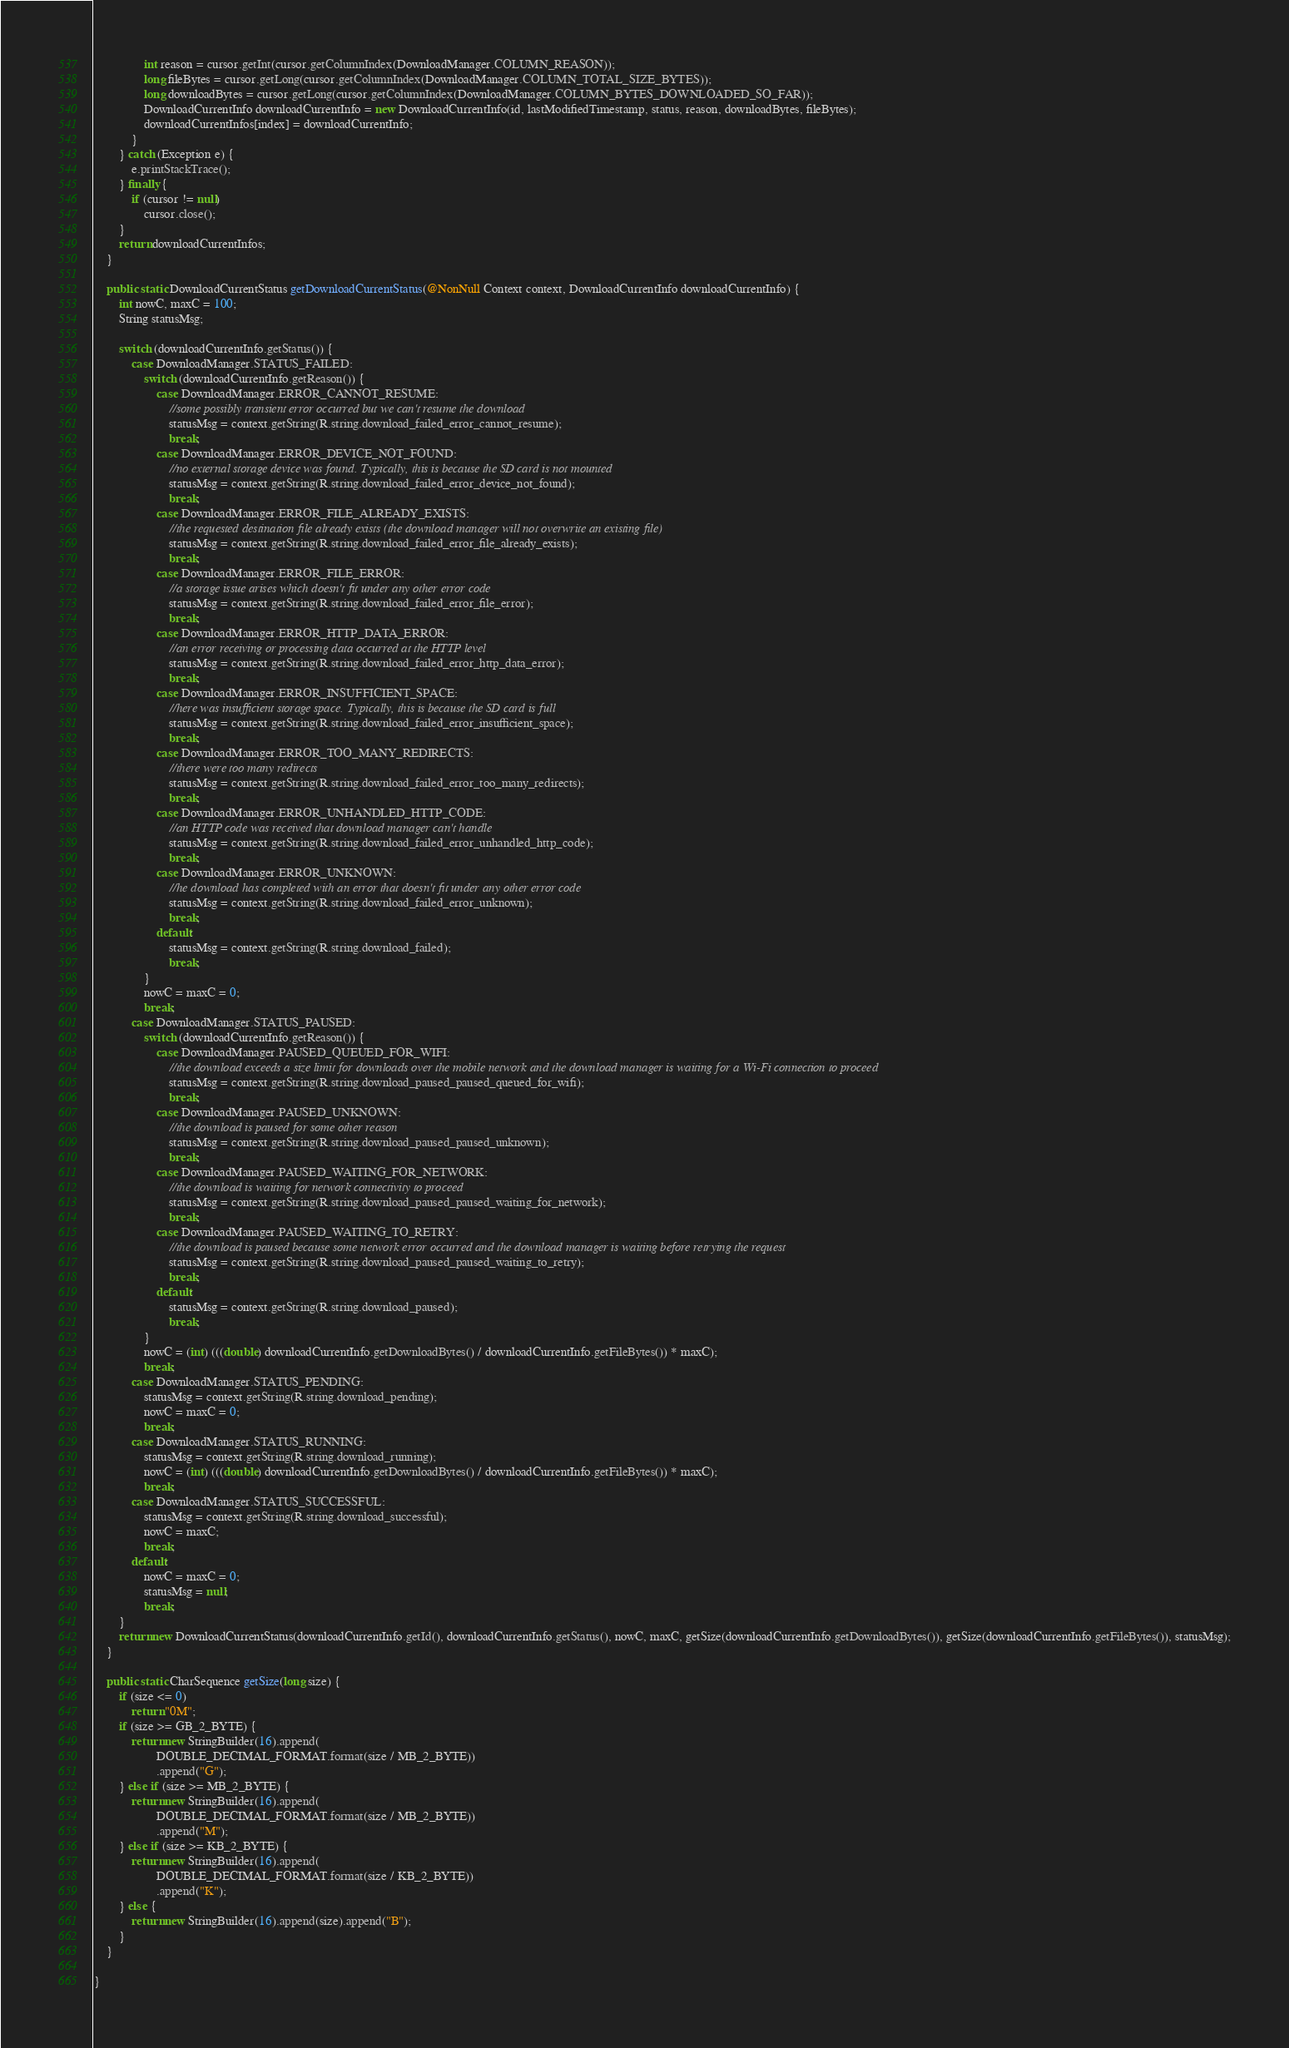<code> <loc_0><loc_0><loc_500><loc_500><_Java_>                int reason = cursor.getInt(cursor.getColumnIndex(DownloadManager.COLUMN_REASON));
                long fileBytes = cursor.getLong(cursor.getColumnIndex(DownloadManager.COLUMN_TOTAL_SIZE_BYTES));
                long downloadBytes = cursor.getLong(cursor.getColumnIndex(DownloadManager.COLUMN_BYTES_DOWNLOADED_SO_FAR));
                DownloadCurrentInfo downloadCurrentInfo = new DownloadCurrentInfo(id, lastModifiedTimestamp, status, reason, downloadBytes, fileBytes);
                downloadCurrentInfos[index] = downloadCurrentInfo;
            }
        } catch (Exception e) {
            e.printStackTrace();
        } finally {
            if (cursor != null)
                cursor.close();
        }
        return downloadCurrentInfos;
    }

    public static DownloadCurrentStatus getDownloadCurrentStatus(@NonNull Context context, DownloadCurrentInfo downloadCurrentInfo) {
        int nowC, maxC = 100;
        String statusMsg;

        switch (downloadCurrentInfo.getStatus()) {
            case DownloadManager.STATUS_FAILED:
                switch (downloadCurrentInfo.getReason()) {
                    case DownloadManager.ERROR_CANNOT_RESUME:
                        //some possibly transient error occurred but we can't resume the download
                        statusMsg = context.getString(R.string.download_failed_error_cannot_resume);
                        break;
                    case DownloadManager.ERROR_DEVICE_NOT_FOUND:
                        //no external storage device was found. Typically, this is because the SD card is not mounted
                        statusMsg = context.getString(R.string.download_failed_error_device_not_found);
                        break;
                    case DownloadManager.ERROR_FILE_ALREADY_EXISTS:
                        //the requested destination file already exists (the download manager will not overwrite an existing file)
                        statusMsg = context.getString(R.string.download_failed_error_file_already_exists);
                        break;
                    case DownloadManager.ERROR_FILE_ERROR:
                        //a storage issue arises which doesn't fit under any other error code
                        statusMsg = context.getString(R.string.download_failed_error_file_error);
                        break;
                    case DownloadManager.ERROR_HTTP_DATA_ERROR:
                        //an error receiving or processing data occurred at the HTTP level
                        statusMsg = context.getString(R.string.download_failed_error_http_data_error);
                        break;
                    case DownloadManager.ERROR_INSUFFICIENT_SPACE:
                        //here was insufficient storage space. Typically, this is because the SD card is full
                        statusMsg = context.getString(R.string.download_failed_error_insufficient_space);
                        break;
                    case DownloadManager.ERROR_TOO_MANY_REDIRECTS:
                        //there were too many redirects
                        statusMsg = context.getString(R.string.download_failed_error_too_many_redirects);
                        break;
                    case DownloadManager.ERROR_UNHANDLED_HTTP_CODE:
                        //an HTTP code was received that download manager can't handle
                        statusMsg = context.getString(R.string.download_failed_error_unhandled_http_code);
                        break;
                    case DownloadManager.ERROR_UNKNOWN:
                        //he download has completed with an error that doesn't fit under any other error code
                        statusMsg = context.getString(R.string.download_failed_error_unknown);
                        break;
                    default:
                        statusMsg = context.getString(R.string.download_failed);
                        break;
                }
                nowC = maxC = 0;
                break;
            case DownloadManager.STATUS_PAUSED:
                switch (downloadCurrentInfo.getReason()) {
                    case DownloadManager.PAUSED_QUEUED_FOR_WIFI:
                        //the download exceeds a size limit for downloads over the mobile network and the download manager is waiting for a Wi-Fi connection to proceed
                        statusMsg = context.getString(R.string.download_paused_paused_queued_for_wifi);
                        break;
                    case DownloadManager.PAUSED_UNKNOWN:
                        //the download is paused for some other reason
                        statusMsg = context.getString(R.string.download_paused_paused_unknown);
                        break;
                    case DownloadManager.PAUSED_WAITING_FOR_NETWORK:
                        //the download is waiting for network connectivity to proceed
                        statusMsg = context.getString(R.string.download_paused_paused_waiting_for_network);
                        break;
                    case DownloadManager.PAUSED_WAITING_TO_RETRY:
                        //the download is paused because some network error occurred and the download manager is waiting before retrying the request
                        statusMsg = context.getString(R.string.download_paused_paused_waiting_to_retry);
                        break;
                    default:
                        statusMsg = context.getString(R.string.download_paused);
                        break;
                }
                nowC = (int) (((double) downloadCurrentInfo.getDownloadBytes() / downloadCurrentInfo.getFileBytes()) * maxC);
                break;
            case DownloadManager.STATUS_PENDING:
                statusMsg = context.getString(R.string.download_pending);
                nowC = maxC = 0;
                break;
            case DownloadManager.STATUS_RUNNING:
                statusMsg = context.getString(R.string.download_running);
                nowC = (int) (((double) downloadCurrentInfo.getDownloadBytes() / downloadCurrentInfo.getFileBytes()) * maxC);
                break;
            case DownloadManager.STATUS_SUCCESSFUL:
                statusMsg = context.getString(R.string.download_successful);
                nowC = maxC;
                break;
            default:
                nowC = maxC = 0;
                statusMsg = null;
                break;
        }
        return new DownloadCurrentStatus(downloadCurrentInfo.getId(), downloadCurrentInfo.getStatus(), nowC, maxC, getSize(downloadCurrentInfo.getDownloadBytes()), getSize(downloadCurrentInfo.getFileBytes()), statusMsg);
    }

    public static CharSequence getSize(long size) {
        if (size <= 0)
            return "0M";
        if (size >= GB_2_BYTE) {
            return new StringBuilder(16).append(
                    DOUBLE_DECIMAL_FORMAT.format(size / MB_2_BYTE))
                    .append("G");
        } else if (size >= MB_2_BYTE) {
            return new StringBuilder(16).append(
                    DOUBLE_DECIMAL_FORMAT.format(size / MB_2_BYTE))
                    .append("M");
        } else if (size >= KB_2_BYTE) {
            return new StringBuilder(16).append(
                    DOUBLE_DECIMAL_FORMAT.format(size / KB_2_BYTE))
                    .append("K");
        } else {
            return new StringBuilder(16).append(size).append("B");
        }
    }

}
</code> 